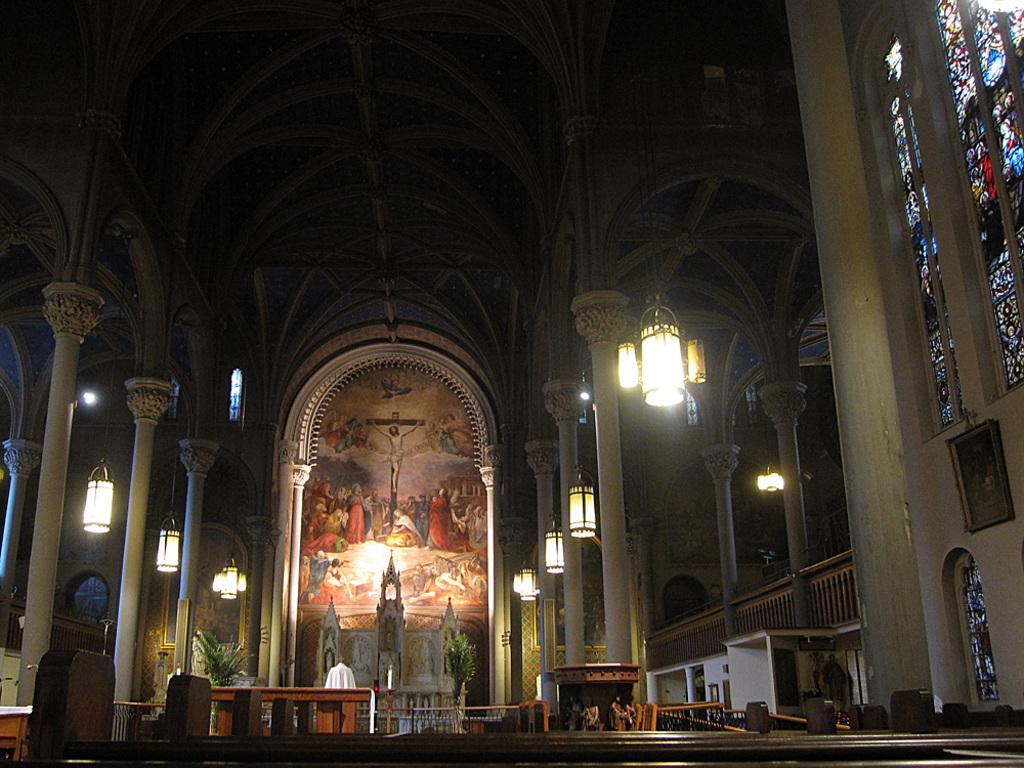What type of location might the image be taken in? The image might be taken in a church. What can be seen illuminating the space in the image? There are lights in the image. What type of seating is present in the image? There are benches in the image. What type of religious artifacts can be seen in the image? There are statues in the image. What type of artwork is present in the image? There is a painting in the image. What type of architectural feature is present in the image? There are pillars in the image. What type of glass can be seen in the image? There is stained glass in the image. What type of barrier or divider is present in the image? There is a wall in the image. What type of vegetable is being used as a cap for the statue in the image? There is no vegetable being used as a cap for the statue in the image. The statues are not wearing any caps or vegetable-based accessories. 